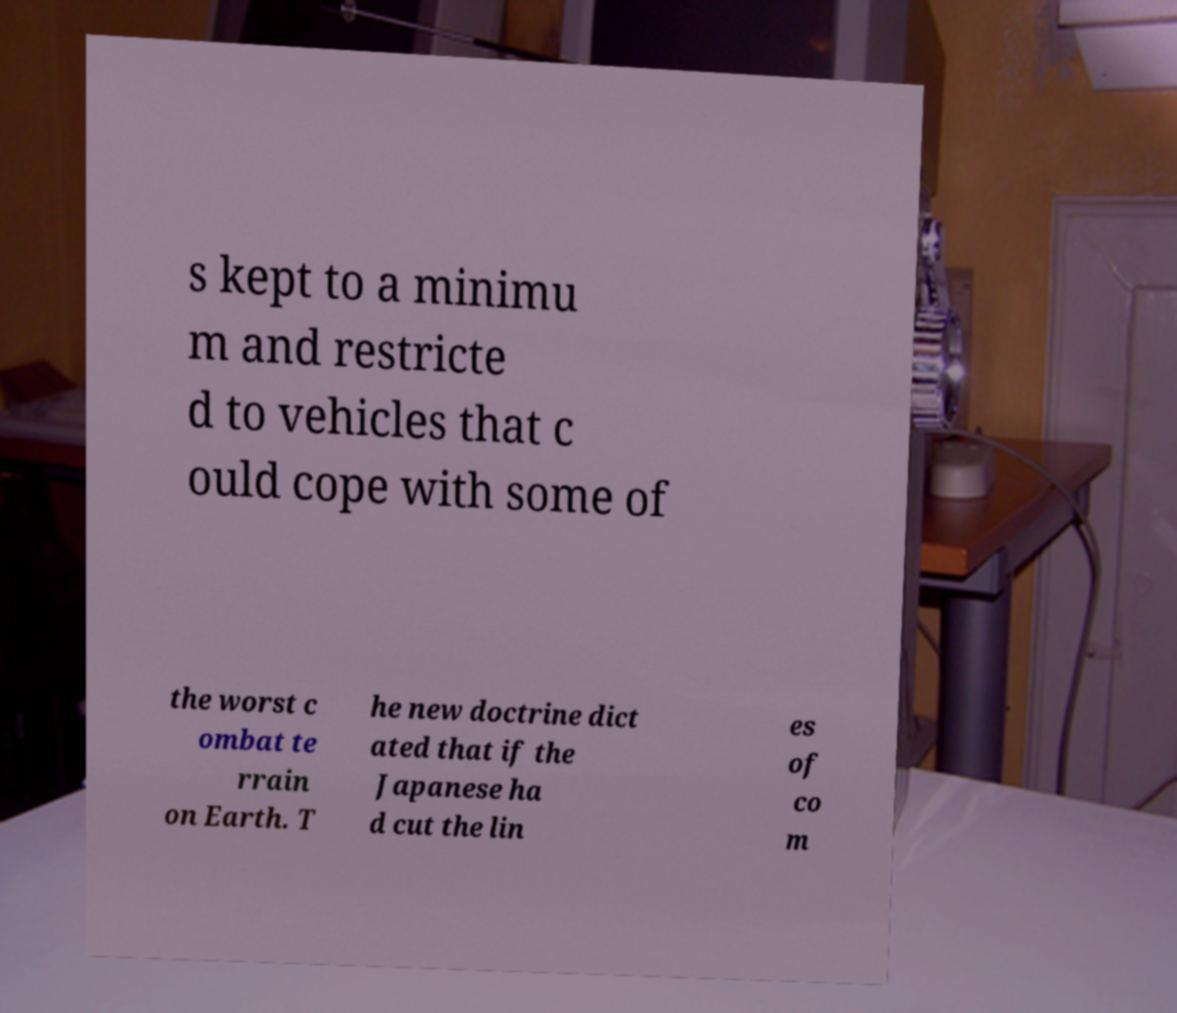Please read and relay the text visible in this image. What does it say? s kept to a minimu m and restricte d to vehicles that c ould cope with some of the worst c ombat te rrain on Earth. T he new doctrine dict ated that if the Japanese ha d cut the lin es of co m 